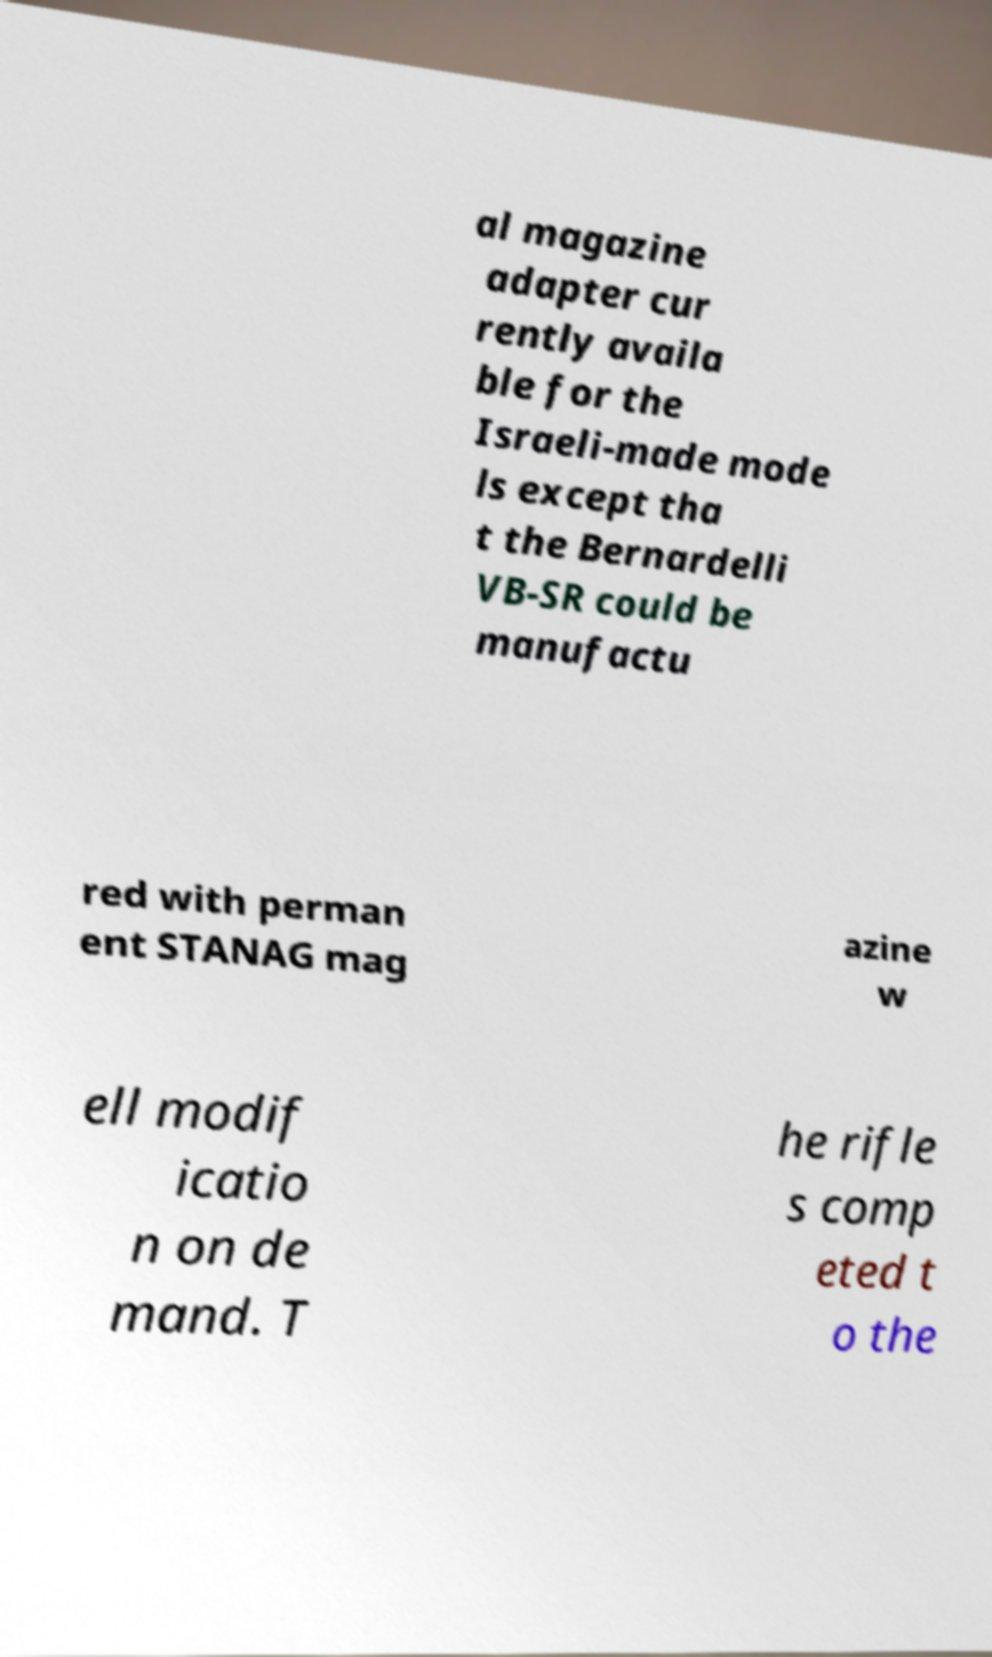Can you read and provide the text displayed in the image?This photo seems to have some interesting text. Can you extract and type it out for me? al magazine adapter cur rently availa ble for the Israeli-made mode ls except tha t the Bernardelli VB-SR could be manufactu red with perman ent STANAG mag azine w ell modif icatio n on de mand. T he rifle s comp eted t o the 